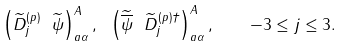<formula> <loc_0><loc_0><loc_500><loc_500>\left ( \widetilde { D } ^ { ( p ) } _ { j } \ \widetilde { \psi } \right ) ^ { A } _ { a \alpha } , \ \left ( \widetilde { \overline { \psi } } \ \widetilde { D } ^ { ( p ) \dagger } _ { j } \right ) ^ { A } _ { a \alpha } , \quad - 3 \leq j \leq 3 .</formula> 